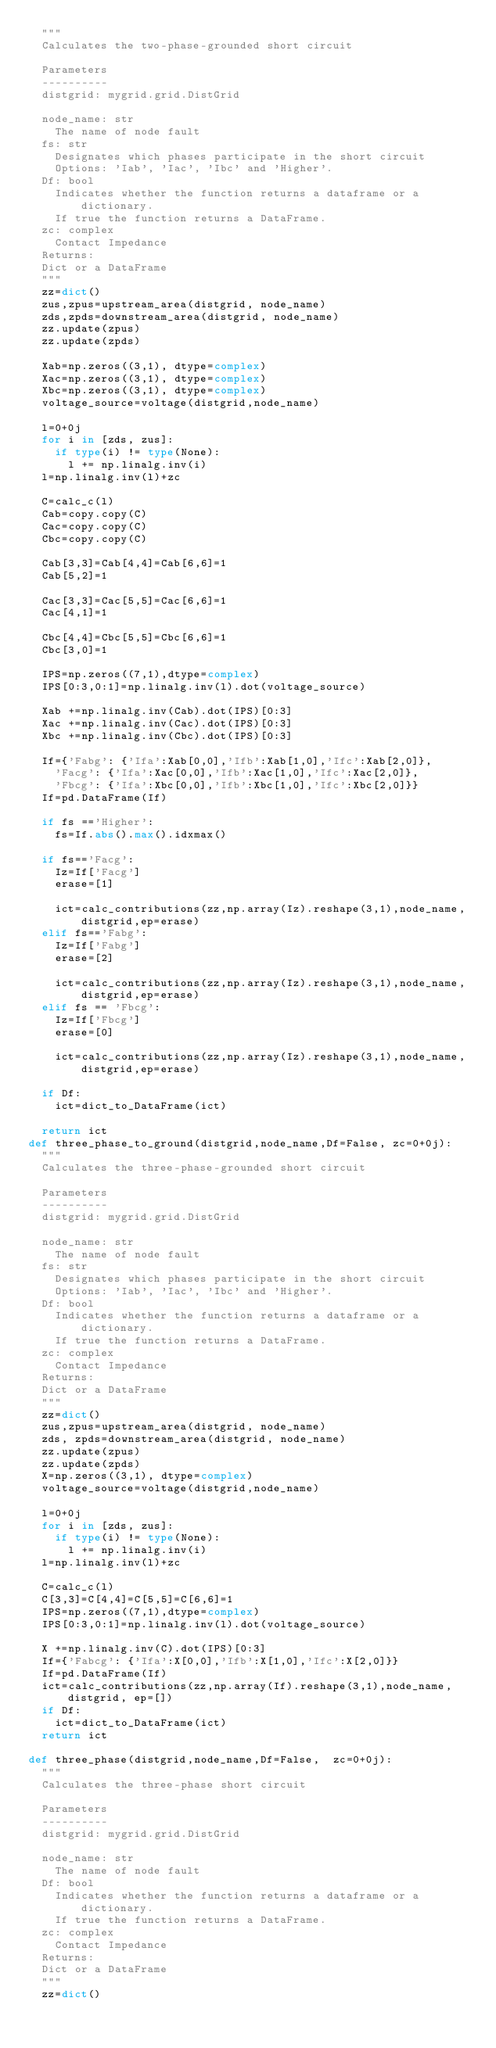Convert code to text. <code><loc_0><loc_0><loc_500><loc_500><_Python_>	"""
	Calculates the two-phase-grounded short circuit

	Parameters
	----------
	distgrid: mygrid.grid.DistGrid

	node_name: str
		The name of node fault
	fs: str
		Designates which phases participate in the short circuit
		Options: 'Iab', 'Iac', 'Ibc' and 'Higher'.
	Df: bool
		Indicates whether the function returns a dataframe or a dictionary.
		If true the function returns a DataFrame.
	zc: complex
		Contact Impedance
	Returns:
	Dict or a DataFrame
	"""
	zz=dict()
	zus,zpus=upstream_area(distgrid, node_name)
	zds,zpds=downstream_area(distgrid, node_name)
	zz.update(zpus)
	zz.update(zpds)

	Xab=np.zeros((3,1), dtype=complex)
	Xac=np.zeros((3,1), dtype=complex)
	Xbc=np.zeros((3,1), dtype=complex)
	voltage_source=voltage(distgrid,node_name)

	l=0+0j
	for i in [zds, zus]:
		if type(i) != type(None):
			l += np.linalg.inv(i)
	l=np.linalg.inv(l)+zc

	C=calc_c(l)
	Cab=copy.copy(C)
	Cac=copy.copy(C)
	Cbc=copy.copy(C)

	Cab[3,3]=Cab[4,4]=Cab[6,6]=1
	Cab[5,2]=1

	Cac[3,3]=Cac[5,5]=Cac[6,6]=1
	Cac[4,1]=1

	Cbc[4,4]=Cbc[5,5]=Cbc[6,6]=1
	Cbc[3,0]=1

	IPS=np.zeros((7,1),dtype=complex)
	IPS[0:3,0:1]=np.linalg.inv(l).dot(voltage_source)

	Xab +=np.linalg.inv(Cab).dot(IPS)[0:3]
	Xac +=np.linalg.inv(Cac).dot(IPS)[0:3]
	Xbc +=np.linalg.inv(Cbc).dot(IPS)[0:3]

	If={'Fabg': {'Ifa':Xab[0,0],'Ifb':Xab[1,0],'Ifc':Xab[2,0]},
		'Facg': {'Ifa':Xac[0,0],'Ifb':Xac[1,0],'Ifc':Xac[2,0]},
		'Fbcg': {'Ifa':Xbc[0,0],'Ifb':Xbc[1,0],'Ifc':Xbc[2,0]}}
	If=pd.DataFrame(If)

	if fs =='Higher':
		fs=If.abs().max().idxmax()

	if fs=='Facg':
		Iz=If['Facg']
		erase=[1]

		ict=calc_contributions(zz,np.array(Iz).reshape(3,1),node_name,distgrid,ep=erase)
	elif fs=='Fabg':
		Iz=If['Fabg']
		erase=[2]

		ict=calc_contributions(zz,np.array(Iz).reshape(3,1),node_name,distgrid,ep=erase)
	elif fs == 'Fbcg':
		Iz=If['Fbcg']
		erase=[0]

		ict=calc_contributions(zz,np.array(Iz).reshape(3,1),node_name,distgrid,ep=erase)

	if Df:
		ict=dict_to_DataFrame(ict)

	return ict
def three_phase_to_ground(distgrid,node_name,Df=False, zc=0+0j):
	"""
	Calculates the three-phase-grounded short circuit

	Parameters
	----------
	distgrid: mygrid.grid.DistGrid

	node_name: str
		The name of node fault
	fs: str
		Designates which phases participate in the short circuit
		Options: 'Iab', 'Iac', 'Ibc' and 'Higher'.
	Df: bool
		Indicates whether the function returns a dataframe or a dictionary.
		If true the function returns a DataFrame.
	zc: complex
		Contact Impedance
	Returns:
	Dict or a DataFrame
	"""
	zz=dict()
	zus,zpus=upstream_area(distgrid, node_name)
	zds, zpds=downstream_area(distgrid, node_name)
	zz.update(zpus)
	zz.update(zpds)
	X=np.zeros((3,1), dtype=complex)
	voltage_source=voltage(distgrid,node_name)

	l=0+0j
	for i in [zds, zus]:
		if type(i) != type(None):
			l += np.linalg.inv(i)
	l=np.linalg.inv(l)+zc

	C=calc_c(l)
	C[3,3]=C[4,4]=C[5,5]=C[6,6]=1
	IPS=np.zeros((7,1),dtype=complex)
	IPS[0:3,0:1]=np.linalg.inv(l).dot(voltage_source)

	X +=np.linalg.inv(C).dot(IPS)[0:3]
	If={'Fabcg': {'Ifa':X[0,0],'Ifb':X[1,0],'Ifc':X[2,0]}}
	If=pd.DataFrame(If)
	ict=calc_contributions(zz,np.array(If).reshape(3,1),node_name,distgrid, ep=[])
	if Df:
		ict=dict_to_DataFrame(ict)
	return ict

def three_phase(distgrid,node_name,Df=False,  zc=0+0j):
	"""
	Calculates the three-phase short circuit

	Parameters
	----------
	distgrid: mygrid.grid.DistGrid

	node_name: str
		The name of node fault
	Df: bool
		Indicates whether the function returns a dataframe or a dictionary.
		If true the function returns a DataFrame.
	zc: complex
		Contact Impedance
	Returns:
	Dict or a DataFrame
	"""
	zz=dict()</code> 